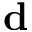Convert formula to latex. <formula><loc_0><loc_0><loc_500><loc_500>d</formula> 